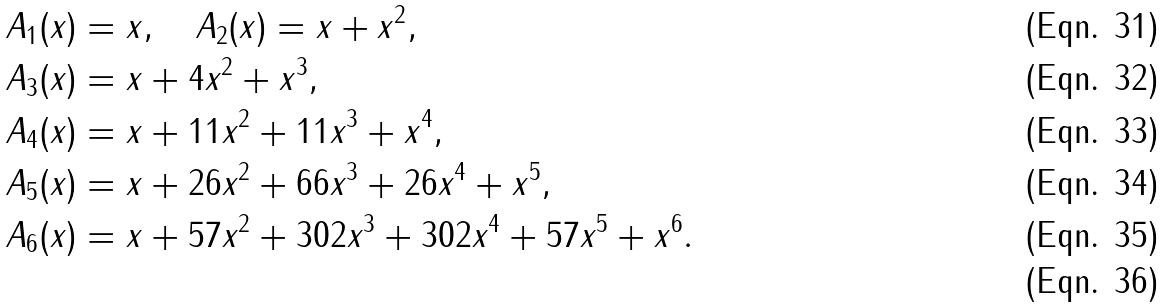<formula> <loc_0><loc_0><loc_500><loc_500>A _ { 1 } ( x ) & = x , \quad A _ { 2 } ( x ) = x + x ^ { 2 } , \\ A _ { 3 } ( x ) & = x + 4 x ^ { 2 } + x ^ { 3 } , \\ A _ { 4 } ( x ) & = x + 1 1 x ^ { 2 } + 1 1 x ^ { 3 } + x ^ { 4 } , \\ A _ { 5 } ( x ) & = x + 2 6 x ^ { 2 } + 6 6 x ^ { 3 } + 2 6 x ^ { 4 } + x ^ { 5 } , \\ A _ { 6 } ( x ) & = x + 5 7 x ^ { 2 } + 3 0 2 x ^ { 3 } + 3 0 2 x ^ { 4 } + 5 7 x ^ { 5 } + x ^ { 6 } . \\</formula> 